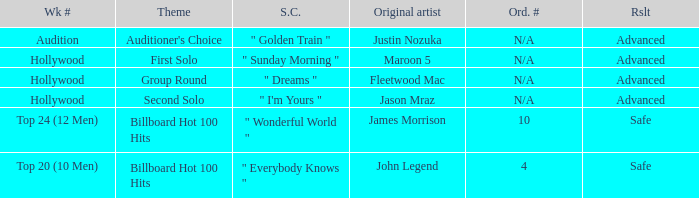What are all the week # where subject matter is auditioner's choice Audition. 